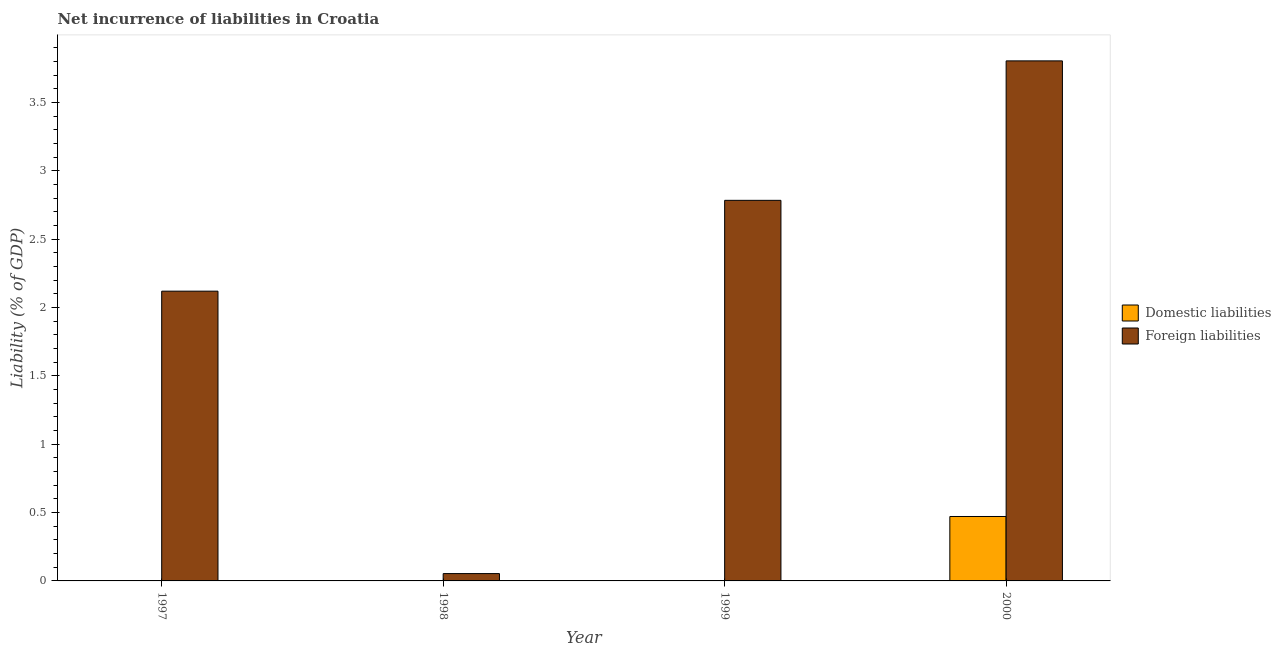How many different coloured bars are there?
Make the answer very short. 2. Are the number of bars on each tick of the X-axis equal?
Offer a very short reply. No. What is the incurrence of foreign liabilities in 2000?
Provide a short and direct response. 3.81. Across all years, what is the maximum incurrence of foreign liabilities?
Your answer should be compact. 3.81. In which year was the incurrence of domestic liabilities maximum?
Your response must be concise. 2000. What is the total incurrence of domestic liabilities in the graph?
Make the answer very short. 0.47. What is the difference between the incurrence of foreign liabilities in 1999 and that in 2000?
Keep it short and to the point. -1.02. What is the difference between the incurrence of foreign liabilities in 1999 and the incurrence of domestic liabilities in 2000?
Your answer should be very brief. -1.02. What is the average incurrence of domestic liabilities per year?
Give a very brief answer. 0.12. In how many years, is the incurrence of domestic liabilities greater than 1.7 %?
Offer a very short reply. 0. What is the ratio of the incurrence of foreign liabilities in 1998 to that in 1999?
Make the answer very short. 0.02. Is the incurrence of foreign liabilities in 1997 less than that in 1998?
Make the answer very short. No. Is the difference between the incurrence of foreign liabilities in 1998 and 1999 greater than the difference between the incurrence of domestic liabilities in 1998 and 1999?
Make the answer very short. No. What is the difference between the highest and the second highest incurrence of foreign liabilities?
Provide a short and direct response. 1.02. What is the difference between the highest and the lowest incurrence of domestic liabilities?
Your answer should be very brief. 0.47. What is the difference between two consecutive major ticks on the Y-axis?
Provide a short and direct response. 0.5. Are the values on the major ticks of Y-axis written in scientific E-notation?
Keep it short and to the point. No. Does the graph contain any zero values?
Offer a very short reply. Yes. Where does the legend appear in the graph?
Your answer should be compact. Center right. How many legend labels are there?
Your answer should be compact. 2. What is the title of the graph?
Provide a short and direct response. Net incurrence of liabilities in Croatia. Does "Time to export" appear as one of the legend labels in the graph?
Offer a very short reply. No. What is the label or title of the X-axis?
Give a very brief answer. Year. What is the label or title of the Y-axis?
Ensure brevity in your answer.  Liability (% of GDP). What is the Liability (% of GDP) in Foreign liabilities in 1997?
Ensure brevity in your answer.  2.12. What is the Liability (% of GDP) in Domestic liabilities in 1998?
Give a very brief answer. 0. What is the Liability (% of GDP) in Foreign liabilities in 1998?
Keep it short and to the point. 0.05. What is the Liability (% of GDP) in Domestic liabilities in 1999?
Ensure brevity in your answer.  0. What is the Liability (% of GDP) in Foreign liabilities in 1999?
Your answer should be very brief. 2.78. What is the Liability (% of GDP) of Domestic liabilities in 2000?
Provide a succinct answer. 0.47. What is the Liability (% of GDP) of Foreign liabilities in 2000?
Offer a terse response. 3.81. Across all years, what is the maximum Liability (% of GDP) in Domestic liabilities?
Your response must be concise. 0.47. Across all years, what is the maximum Liability (% of GDP) of Foreign liabilities?
Provide a short and direct response. 3.81. Across all years, what is the minimum Liability (% of GDP) in Domestic liabilities?
Keep it short and to the point. 0. Across all years, what is the minimum Liability (% of GDP) of Foreign liabilities?
Your answer should be very brief. 0.05. What is the total Liability (% of GDP) in Domestic liabilities in the graph?
Make the answer very short. 0.47. What is the total Liability (% of GDP) of Foreign liabilities in the graph?
Ensure brevity in your answer.  8.76. What is the difference between the Liability (% of GDP) in Foreign liabilities in 1997 and that in 1998?
Ensure brevity in your answer.  2.07. What is the difference between the Liability (% of GDP) of Foreign liabilities in 1997 and that in 1999?
Your answer should be very brief. -0.66. What is the difference between the Liability (% of GDP) in Foreign liabilities in 1997 and that in 2000?
Make the answer very short. -1.69. What is the difference between the Liability (% of GDP) of Foreign liabilities in 1998 and that in 1999?
Ensure brevity in your answer.  -2.73. What is the difference between the Liability (% of GDP) of Foreign liabilities in 1998 and that in 2000?
Make the answer very short. -3.75. What is the difference between the Liability (% of GDP) of Foreign liabilities in 1999 and that in 2000?
Your response must be concise. -1.02. What is the average Liability (% of GDP) of Domestic liabilities per year?
Keep it short and to the point. 0.12. What is the average Liability (% of GDP) of Foreign liabilities per year?
Offer a terse response. 2.19. In the year 2000, what is the difference between the Liability (% of GDP) of Domestic liabilities and Liability (% of GDP) of Foreign liabilities?
Your answer should be compact. -3.33. What is the ratio of the Liability (% of GDP) of Foreign liabilities in 1997 to that in 1998?
Your response must be concise. 39.52. What is the ratio of the Liability (% of GDP) in Foreign liabilities in 1997 to that in 1999?
Provide a succinct answer. 0.76. What is the ratio of the Liability (% of GDP) in Foreign liabilities in 1997 to that in 2000?
Offer a terse response. 0.56. What is the ratio of the Liability (% of GDP) in Foreign liabilities in 1998 to that in 1999?
Your answer should be very brief. 0.02. What is the ratio of the Liability (% of GDP) in Foreign liabilities in 1998 to that in 2000?
Provide a short and direct response. 0.01. What is the ratio of the Liability (% of GDP) of Foreign liabilities in 1999 to that in 2000?
Provide a short and direct response. 0.73. What is the difference between the highest and the second highest Liability (% of GDP) in Foreign liabilities?
Your response must be concise. 1.02. What is the difference between the highest and the lowest Liability (% of GDP) in Domestic liabilities?
Give a very brief answer. 0.47. What is the difference between the highest and the lowest Liability (% of GDP) in Foreign liabilities?
Your response must be concise. 3.75. 